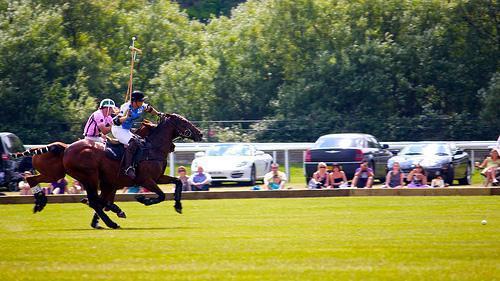How many animals are shown?
Give a very brief answer. 2. How many white balls are shown?
Give a very brief answer. 1. 